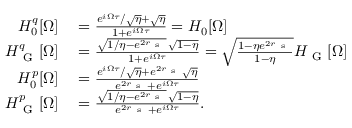Convert formula to latex. <formula><loc_0><loc_0><loc_500><loc_500>\begin{array} { r l } { H _ { 0 } ^ { q } [ \Omega ] } & = \frac { e ^ { i \Omega \tau } / \sqrt { \eta } + \sqrt { \eta } } { 1 + e ^ { i \Omega \tau } } = H _ { 0 } [ \Omega ] } \\ { H _ { G } ^ { q } [ \Omega ] } & = \frac { \sqrt { 1 / \eta - e ^ { 2 r _ { s } } } \, \sqrt { 1 - \eta } } { 1 + e ^ { i \Omega \tau } } = \sqrt { \frac { 1 - \eta e ^ { 2 r _ { s } } } { 1 - \eta } } H _ { G } [ \Omega ] } \\ { H _ { 0 } ^ { p } [ \Omega ] } & = \frac { e ^ { i \Omega \tau } / \sqrt { \eta } + e ^ { 2 r _ { s } } \sqrt { \eta } } { e ^ { 2 r _ { s } } + e ^ { i \Omega \tau } } } \\ { H _ { G } ^ { p } [ \Omega ] } & = \frac { \sqrt { 1 / \eta - e ^ { 2 r _ { s } } } \, \sqrt { 1 - \eta } } { e ^ { 2 r _ { s } } + e ^ { i \Omega \tau } } . } \end{array}</formula> 